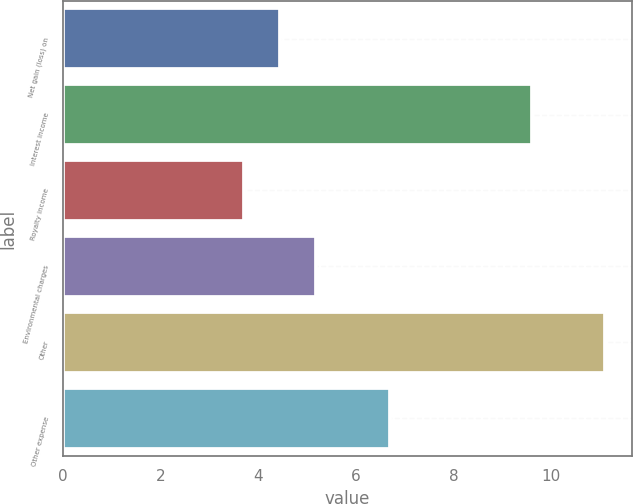Convert chart to OTSL. <chart><loc_0><loc_0><loc_500><loc_500><bar_chart><fcel>Net gain (loss) on<fcel>Interest income<fcel>Royalty income<fcel>Environmental charges<fcel>Other<fcel>Other expense<nl><fcel>4.44<fcel>9.6<fcel>3.7<fcel>5.18<fcel>11.1<fcel>6.7<nl></chart> 